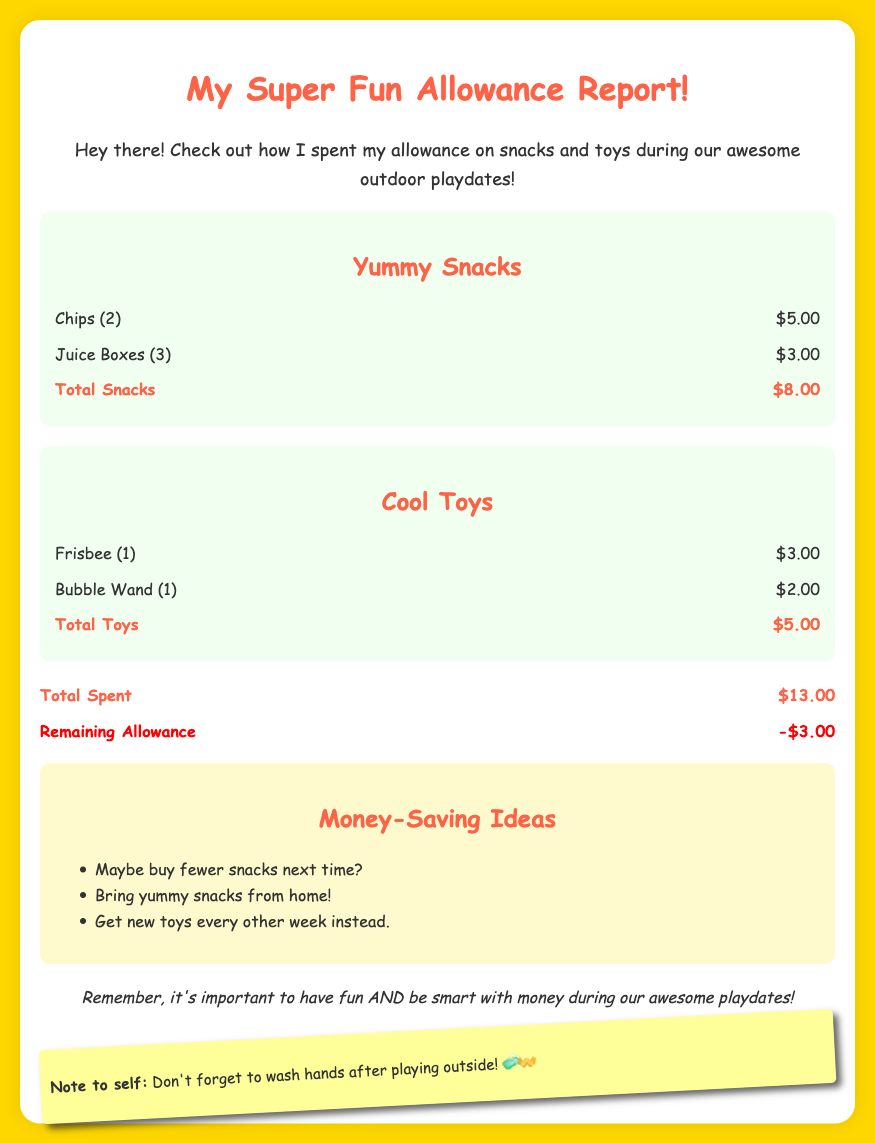What is the total spent? The total spent is the sum of expenses for snacks and toys, which is $8.00 + $5.00 = $13.00.
Answer: $13.00 How much did the chips cost? The cost for chips is listed under snacks in the expense category, which is $5.00.
Answer: $5.00 What is the total cost for toys? The total cost for toys is the sum of the individual toy expenses, which is $3.00 + $2.00 = $5.00.
Answer: $5.00 What is the remaining allowance? The remaining allowance is calculated as total allowance minus total spent, which shows a deficit of $3.00.
Answer: -$3.00 How many juice boxes were bought? The number of juice boxes is specified in the snacks section, which is 3.
Answer: 3 What does the document suggest to save money? The recommendations section lists ways to save money, including buying fewer snacks.
Answer: Buy fewer snacks What type of report is this? This document represents a report focused on personal allowance expenditures.
Answer: Financial report How many total items were purchased? The total items are calculated by adding the amounts for snacks and toys: 2 chips + 3 juice boxes + 1 frisbee + 1 bubble wand = 7 total items.
Answer: 7 What is the style of the document? The style of the document is playful and colorful, aimed at a young audience.
Answer: Playful 